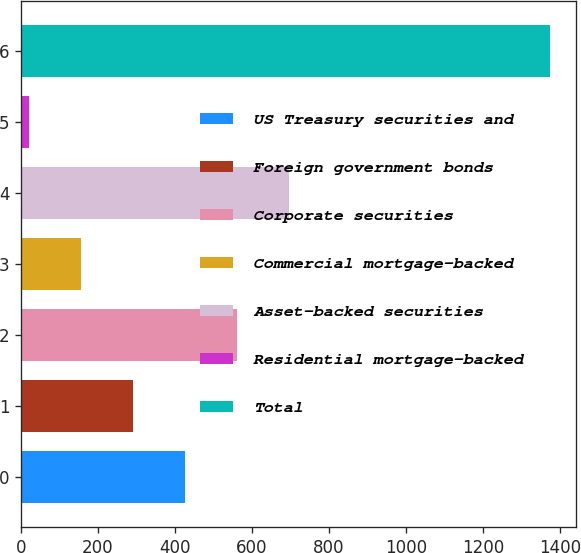<chart> <loc_0><loc_0><loc_500><loc_500><bar_chart><fcel>US Treasury securities and<fcel>Foreign government bonds<fcel>Corporate securities<fcel>Commercial mortgage-backed<fcel>Asset-backed securities<fcel>Residential mortgage-backed<fcel>Total<nl><fcel>426.9<fcel>291.6<fcel>562.2<fcel>156.3<fcel>697.5<fcel>21<fcel>1374<nl></chart> 